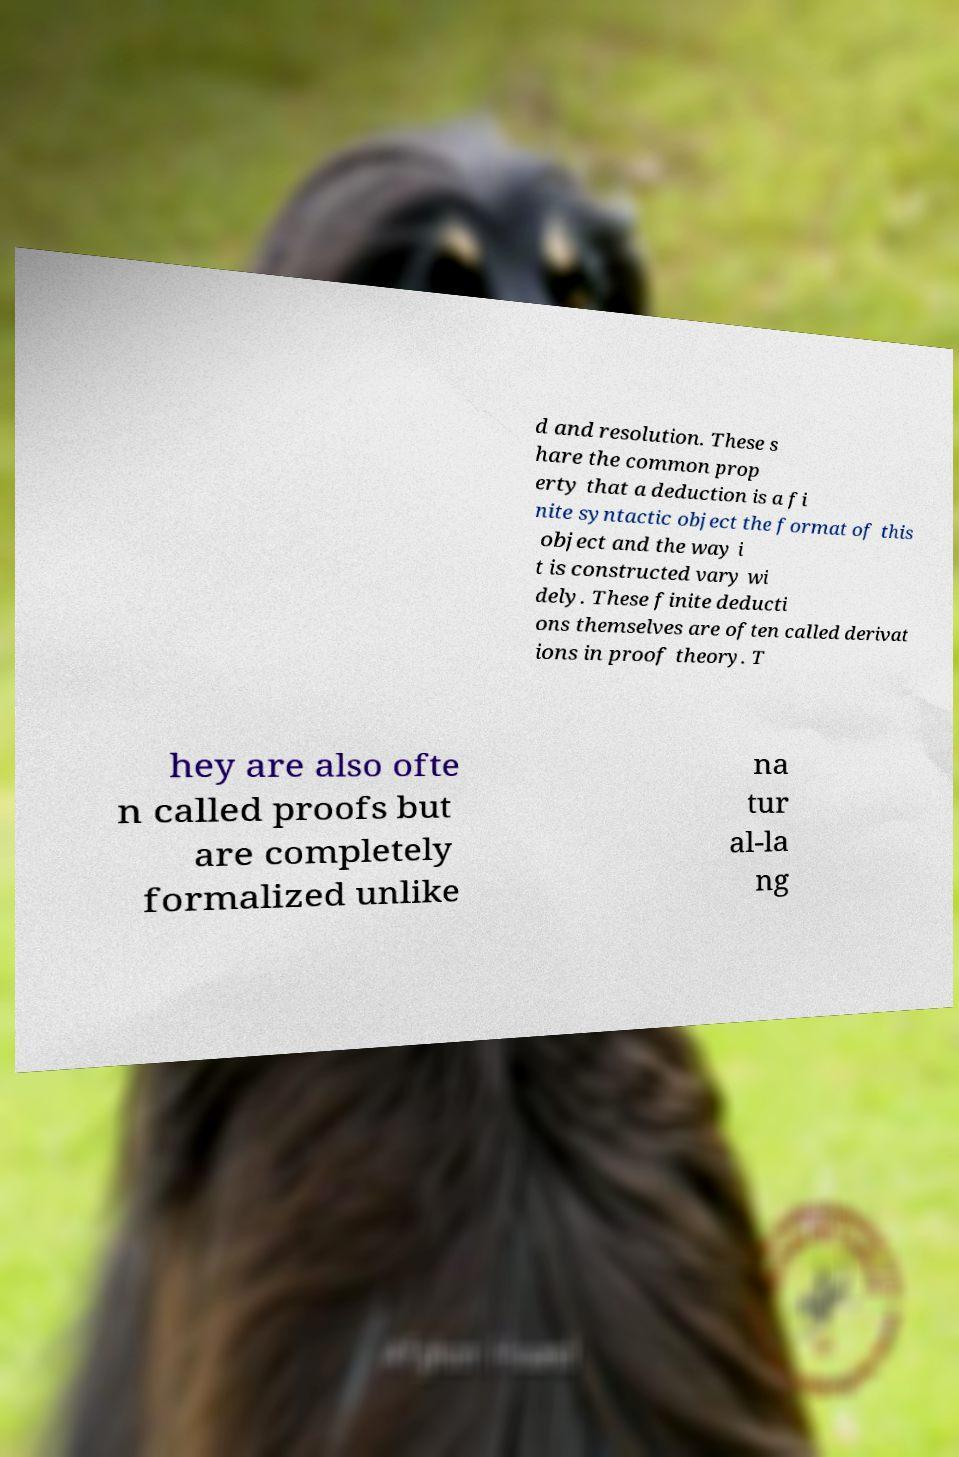Please read and relay the text visible in this image. What does it say? d and resolution. These s hare the common prop erty that a deduction is a fi nite syntactic object the format of this object and the way i t is constructed vary wi dely. These finite deducti ons themselves are often called derivat ions in proof theory. T hey are also ofte n called proofs but are completely formalized unlike na tur al-la ng 